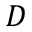<formula> <loc_0><loc_0><loc_500><loc_500>D</formula> 